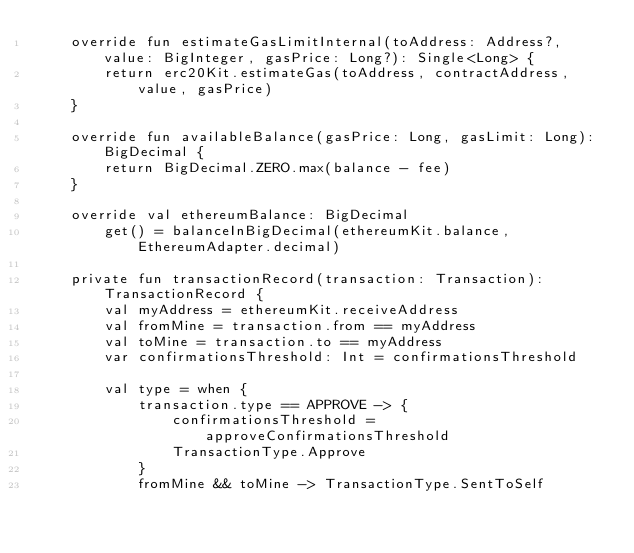Convert code to text. <code><loc_0><loc_0><loc_500><loc_500><_Kotlin_>    override fun estimateGasLimitInternal(toAddress: Address?, value: BigInteger, gasPrice: Long?): Single<Long> {
        return erc20Kit.estimateGas(toAddress, contractAddress, value, gasPrice)
    }

    override fun availableBalance(gasPrice: Long, gasLimit: Long): BigDecimal {
        return BigDecimal.ZERO.max(balance - fee)
    }

    override val ethereumBalance: BigDecimal
        get() = balanceInBigDecimal(ethereumKit.balance, EthereumAdapter.decimal)

    private fun transactionRecord(transaction: Transaction): TransactionRecord {
        val myAddress = ethereumKit.receiveAddress
        val fromMine = transaction.from == myAddress
        val toMine = transaction.to == myAddress
        var confirmationsThreshold: Int = confirmationsThreshold

        val type = when {
            transaction.type == APPROVE -> {
                confirmationsThreshold = approveConfirmationsThreshold
                TransactionType.Approve
            }
            fromMine && toMine -> TransactionType.SentToSelf</code> 